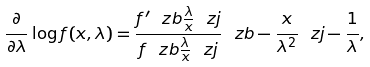Convert formula to latex. <formula><loc_0><loc_0><loc_500><loc_500>\frac { \partial } { \partial \lambda } \log f ( x , \lambda ) = \frac { f ^ { \prime } \ z b \frac { \lambda } { x } \ z j } { f \ z b \frac { \lambda } { x } \ z j } \ z b - \frac { x } { \lambda ^ { 2 } } \ z j - \frac { 1 } { \lambda } ,</formula> 